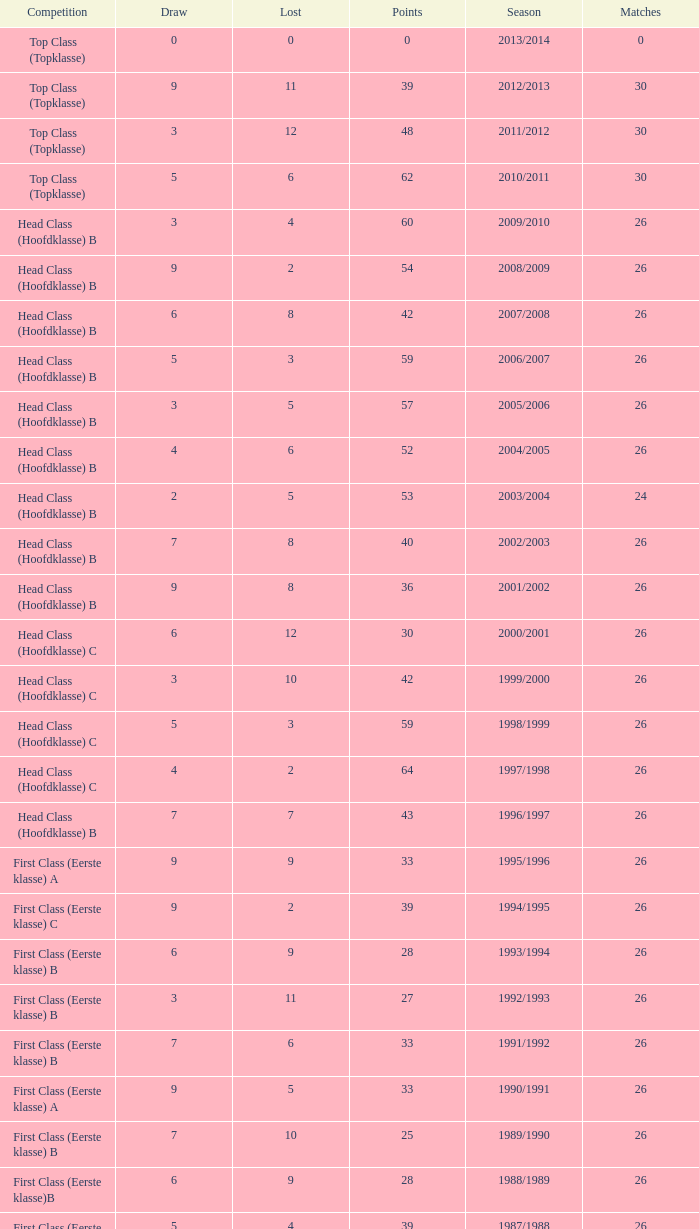What is the sum of the losses that a match score larger than 26, a points score of 62, and a draw greater than 5? None. 